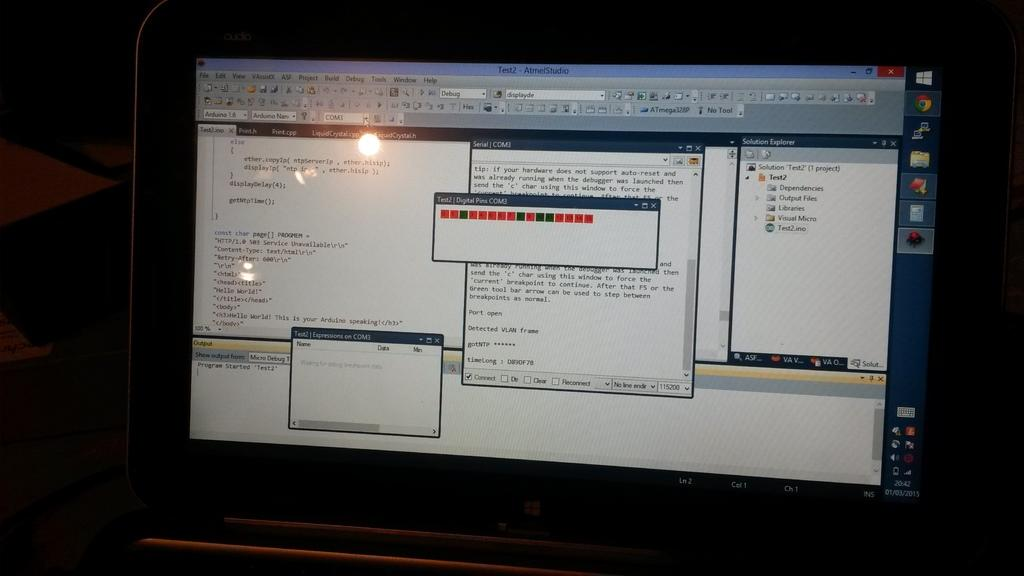<image>
Offer a succinct explanation of the picture presented. Several open windows of the AtmelStudio program on a computer screen. 